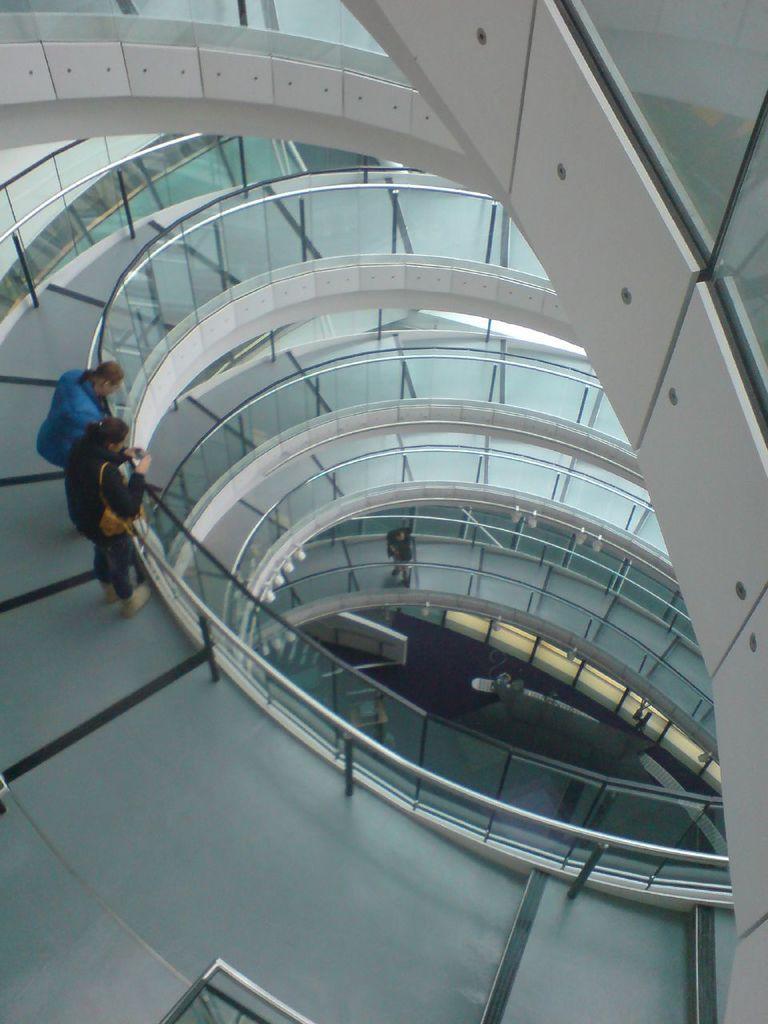How would you summarize this image in a sentence or two? In this picture there is a woman who is wearing black dress, beside that there is a man who is wearing blue jacket. Both of them are standing near to the reeling. On the right we can see the round steps 